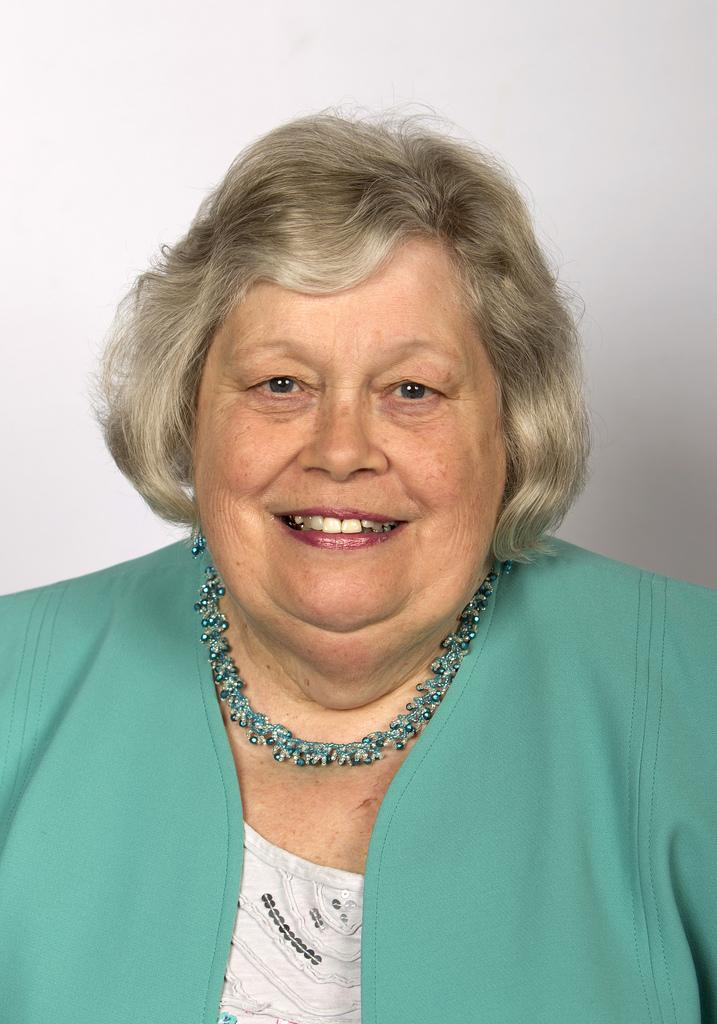Who is the main subject in the image? There is a woman in the image. Where is the woman located in the image? The woman is in the middle of the image. What expression does the woman have? The woman is smiling. What color is the background of the image? The background of the image is white. What type of rabbit can be seen in the lunchroom in the image? There is no rabbit or lunchroom present in the image; it features a woman with a white background. 